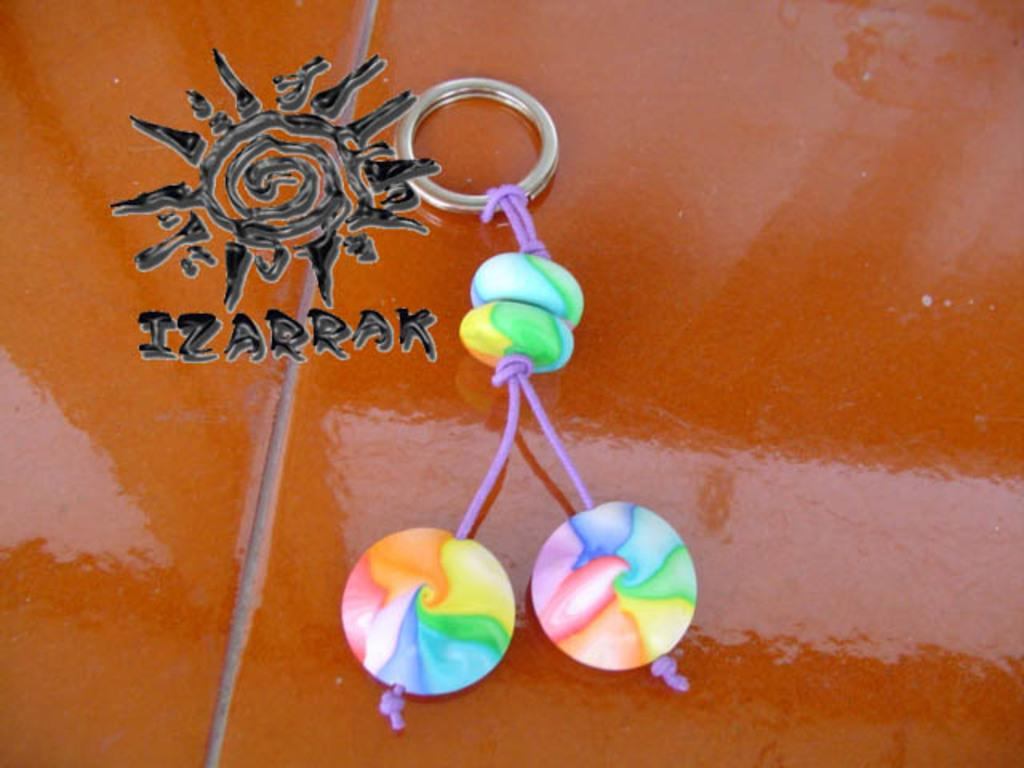What object can be seen in the image? There is a keychain in the image. What is the keychain placed on? The keychain is placed on an orange colored surface. What other object is visible in the image? There is a stick in the image. Can you describe any imperfections or marks in the image? There is a water mark in the image. How many kittens can be seen playing with the stick in the image? There are no kittens present in the image, and therefore no such activity can be observed. 